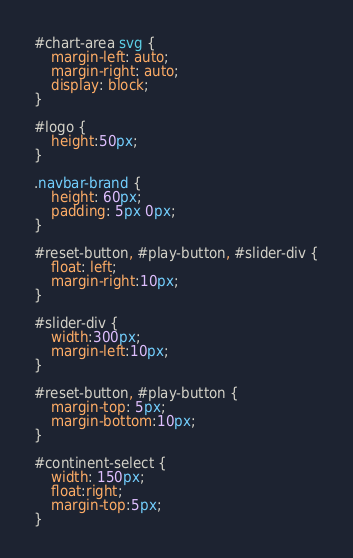Convert code to text. <code><loc_0><loc_0><loc_500><loc_500><_CSS_>#chart-area svg {
	margin-left: auto;
    margin-right: auto;
    display: block;
}

#logo {
	height:50px;
}

.navbar-brand {
	height: 60px;
	padding: 5px 0px;
}

#reset-button, #play-button, #slider-div {
	float: left;
	margin-right:10px;
}

#slider-div {
	width:300px;
	margin-left:10px;
}

#reset-button, #play-button {
	margin-top: 5px;
	margin-bottom:10px;
}

#continent-select {
	width: 150px;
	float:right;
	margin-top:5px;
}

</code> 